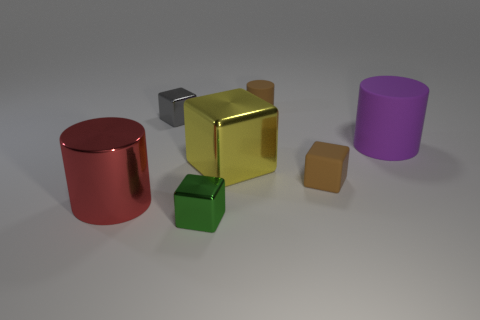Subtract all brown cubes. Subtract all purple balls. How many cubes are left? 3 Add 3 large cyan metallic cylinders. How many objects exist? 10 Subtract all blocks. How many objects are left? 3 Add 3 metal cylinders. How many metal cylinders are left? 4 Add 4 red shiny objects. How many red shiny objects exist? 5 Subtract 0 purple balls. How many objects are left? 7 Subtract all small brown things. Subtract all small shiny blocks. How many objects are left? 3 